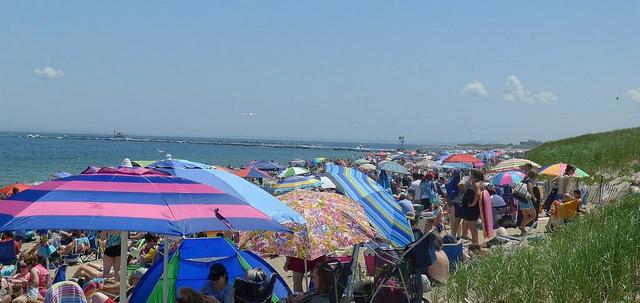How would you describe the weather?
Be succinct. Sunny. Are there a lot of people?
Answer briefly. Yes. What are these umbrellas blocking?
Concise answer only. Sun. 